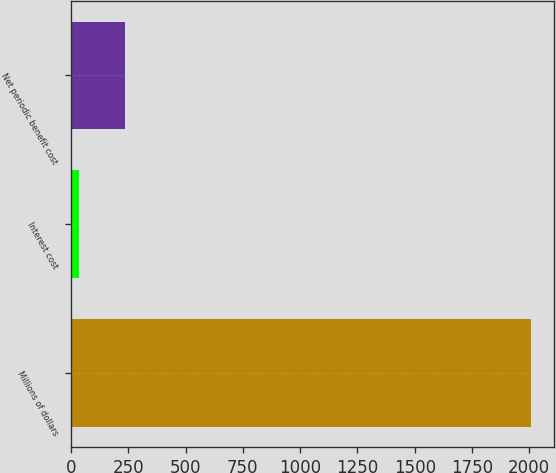Convert chart. <chart><loc_0><loc_0><loc_500><loc_500><bar_chart><fcel>Millions of dollars<fcel>Interest cost<fcel>Net periodic benefit cost<nl><fcel>2006<fcel>37<fcel>233.9<nl></chart> 